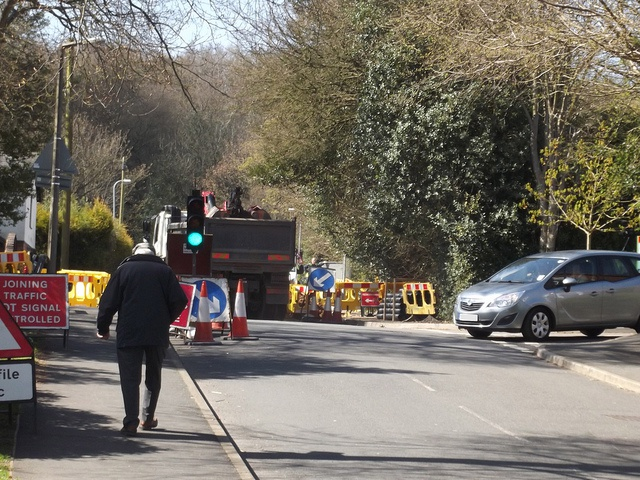Describe the objects in this image and their specific colors. I can see car in darkgray, gray, and black tones, people in darkgray, black, and gray tones, truck in darkgray, black, maroon, and gray tones, traffic light in darkgray, black, cyan, and teal tones, and people in darkgray, black, and gray tones in this image. 